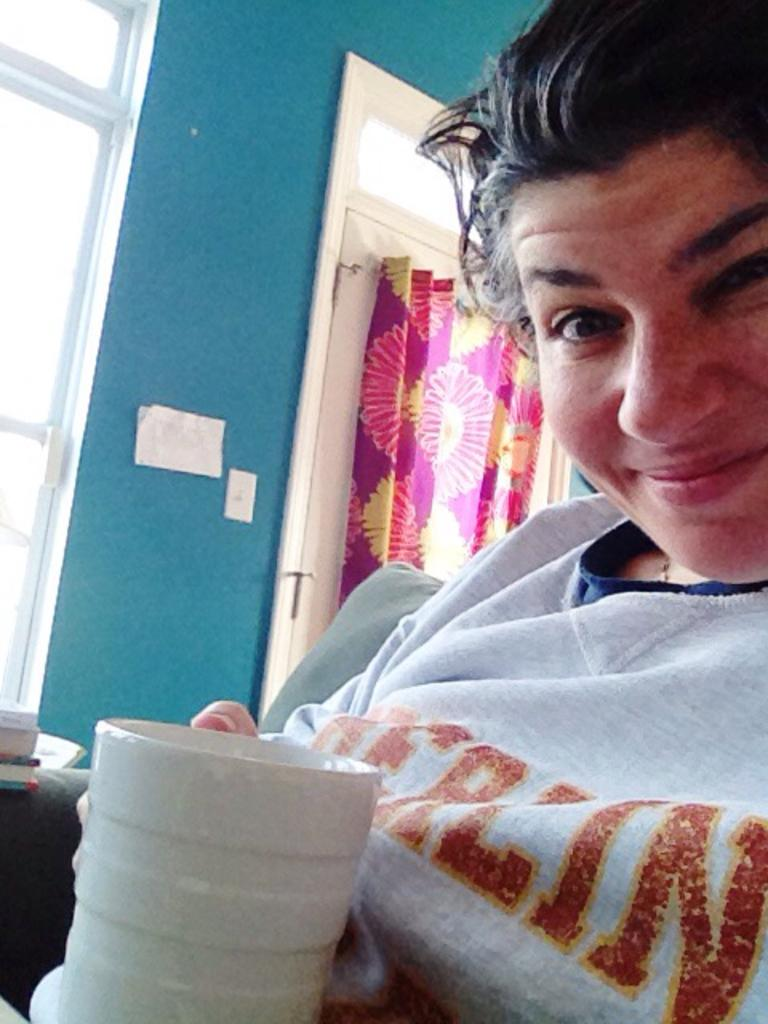Who is present in the image? There is a woman in the image. What is the woman holding in the image? The woman is holding a white cup. What type of clothing is the woman wearing? The woman is wearing a t-shirt. What can be seen in the middle of the image? There is a curtain in the middle of the image. What type of fowl can be seen swimming in the lake in the image? There is no lake or fowl present in the image; it features a woman holding a white cup and a curtain in the middle. 